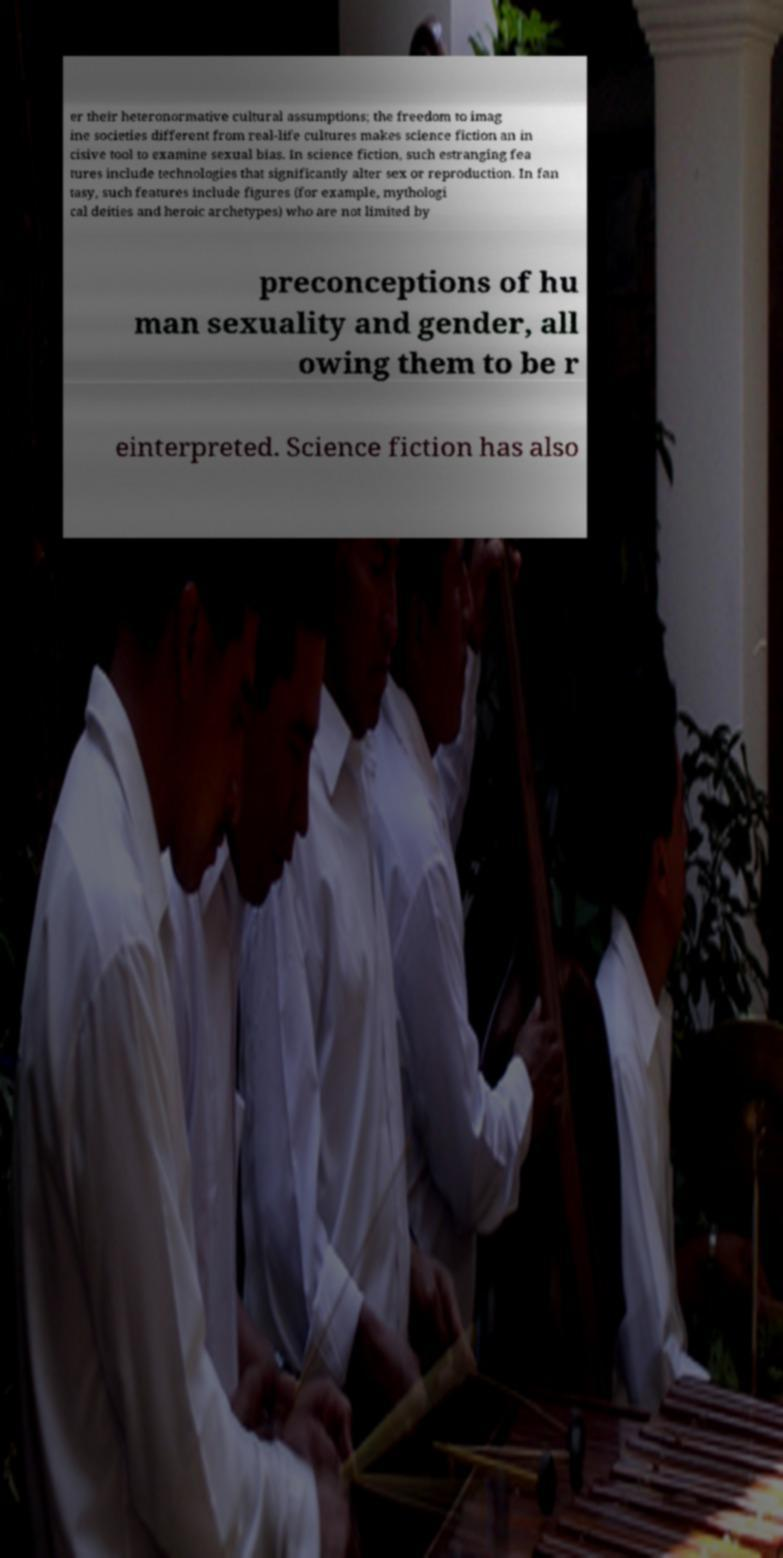For documentation purposes, I need the text within this image transcribed. Could you provide that? er their heteronormative cultural assumptions; the freedom to imag ine societies different from real-life cultures makes science fiction an in cisive tool to examine sexual bias. In science fiction, such estranging fea tures include technologies that significantly alter sex or reproduction. In fan tasy, such features include figures (for example, mythologi cal deities and heroic archetypes) who are not limited by preconceptions of hu man sexuality and gender, all owing them to be r einterpreted. Science fiction has also 